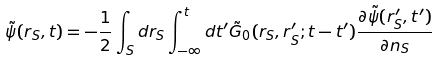<formula> <loc_0><loc_0><loc_500><loc_500>\tilde { \psi } ( r _ { S } , t ) = - \frac { 1 } { 2 } \int _ { S } d r _ { S } \int _ { - \infty } ^ { t } d t ^ { \prime } \tilde { G } _ { 0 } ( r _ { S } , r ^ { \prime } _ { S } ; t - t ^ { \prime } ) \frac { \partial \tilde { \psi } ( r _ { S } ^ { \prime } , t ^ { \prime } ) } { \partial n _ { S } }</formula> 